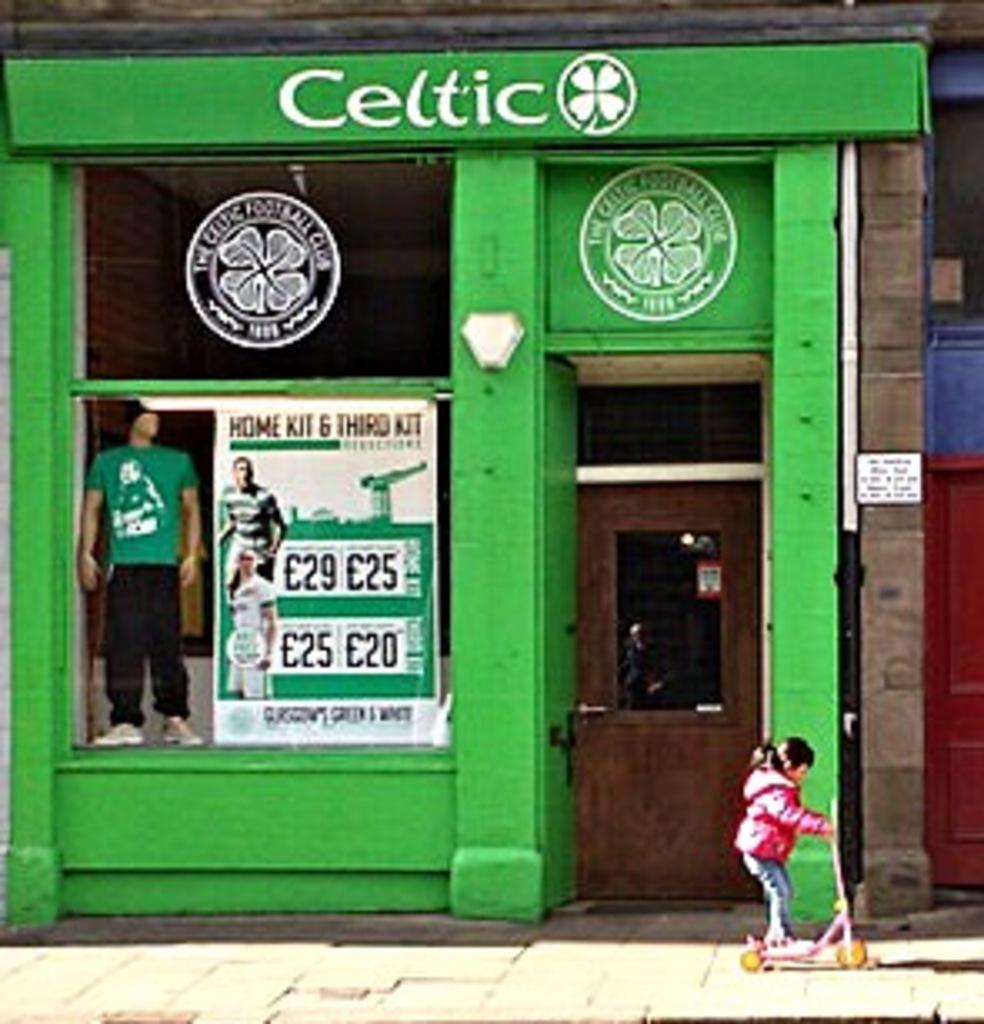What type of establishment is depicted in the image? There is a store in the image. What activity is the girl engaged in? The girl is playing with a foot scooter in the image. What type of display can be seen in the store? There is a mannequin in the image. What type of signage is present in the store? There is a poster in the image. How can customers enter or exit the store? There is a door in the image. What type of bird can be seen creating an order in the image? There are no birds or orders present in the image. 